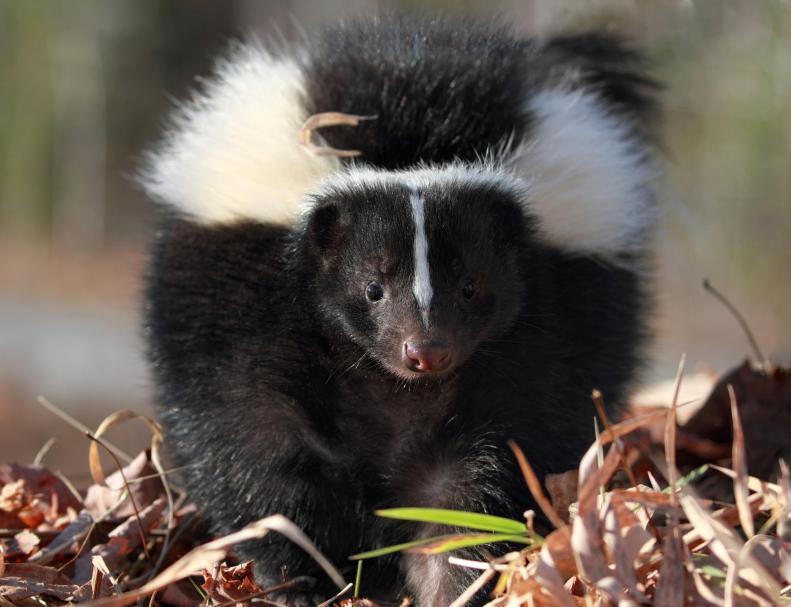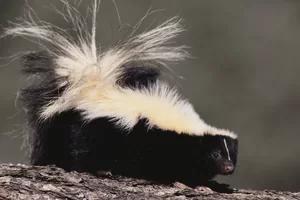The first image is the image on the left, the second image is the image on the right. Considering the images on both sides, is "The skunk in the right image is facing right." valid? Answer yes or no. Yes. The first image is the image on the left, the second image is the image on the right. Examine the images to the left and right. Is the description "One skunk is on all fours facing directly forward, and the other skunk is standing on all fours with its body turned rightward and gaze angled forward." accurate? Answer yes or no. Yes. 